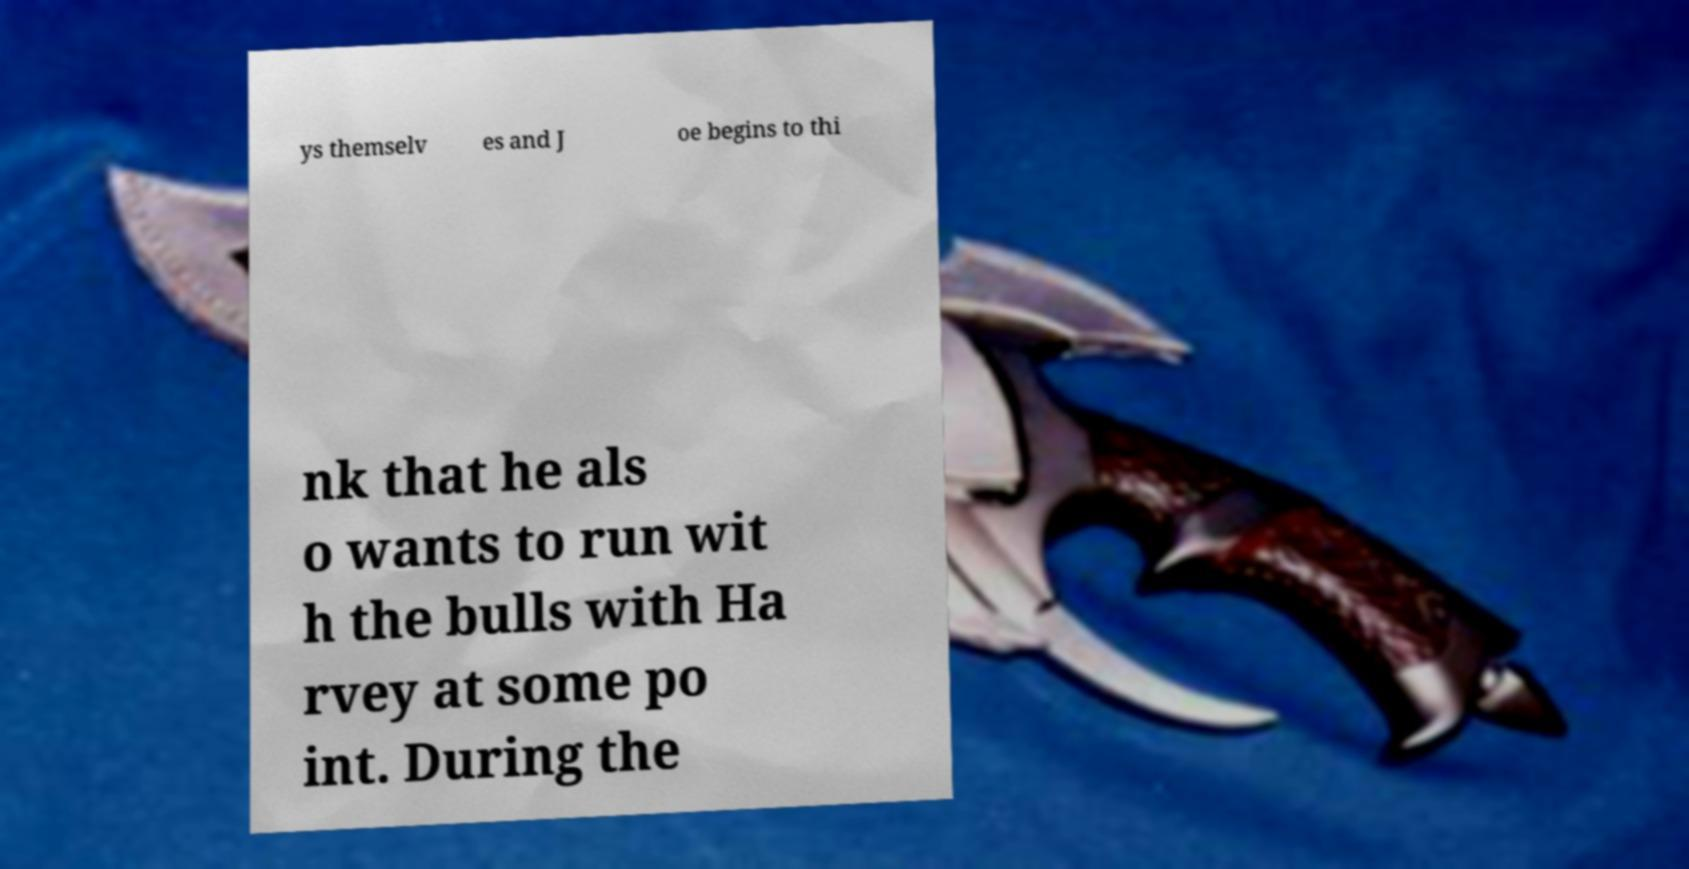Please read and relay the text visible in this image. What does it say? ys themselv es and J oe begins to thi nk that he als o wants to run wit h the bulls with Ha rvey at some po int. During the 